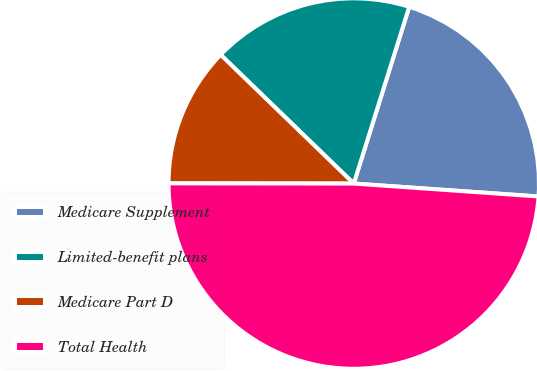Convert chart to OTSL. <chart><loc_0><loc_0><loc_500><loc_500><pie_chart><fcel>Medicare Supplement<fcel>Limited-benefit plans<fcel>Medicare Part D<fcel>Total Health<nl><fcel>21.27%<fcel>17.6%<fcel>12.22%<fcel>48.9%<nl></chart> 